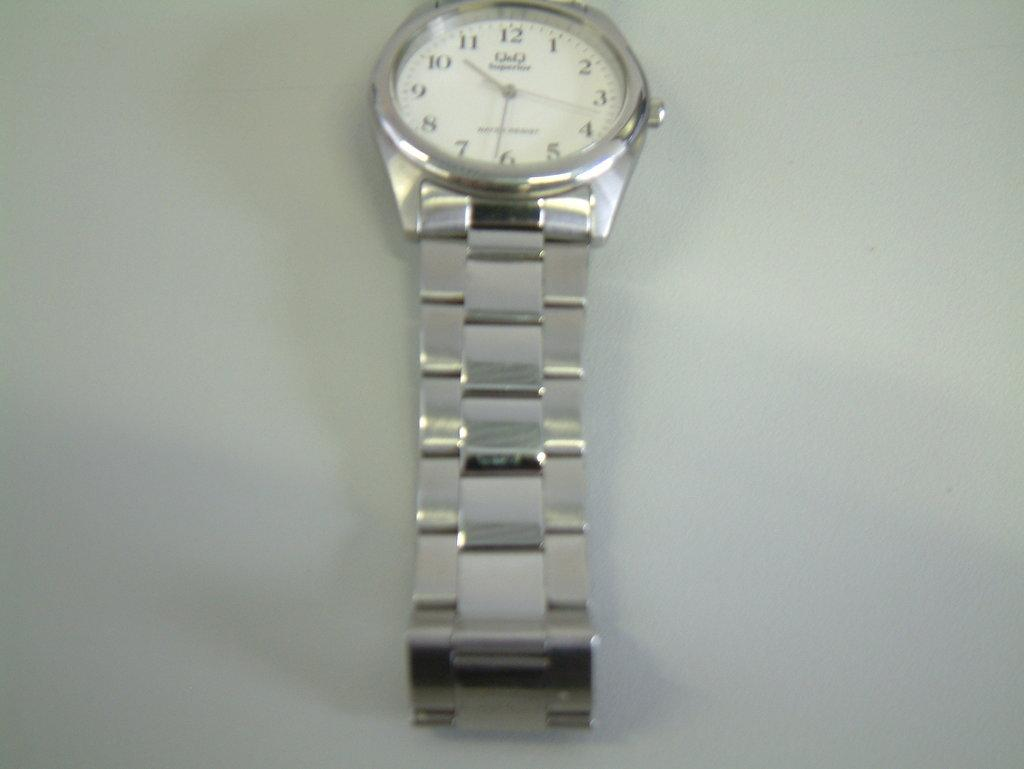<image>
Share a concise interpretation of the image provided. The face of a silver wristwatch, the time is shown to be 10:31. 